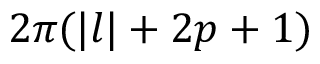<formula> <loc_0><loc_0><loc_500><loc_500>2 \pi ( | l | + 2 p + 1 )</formula> 